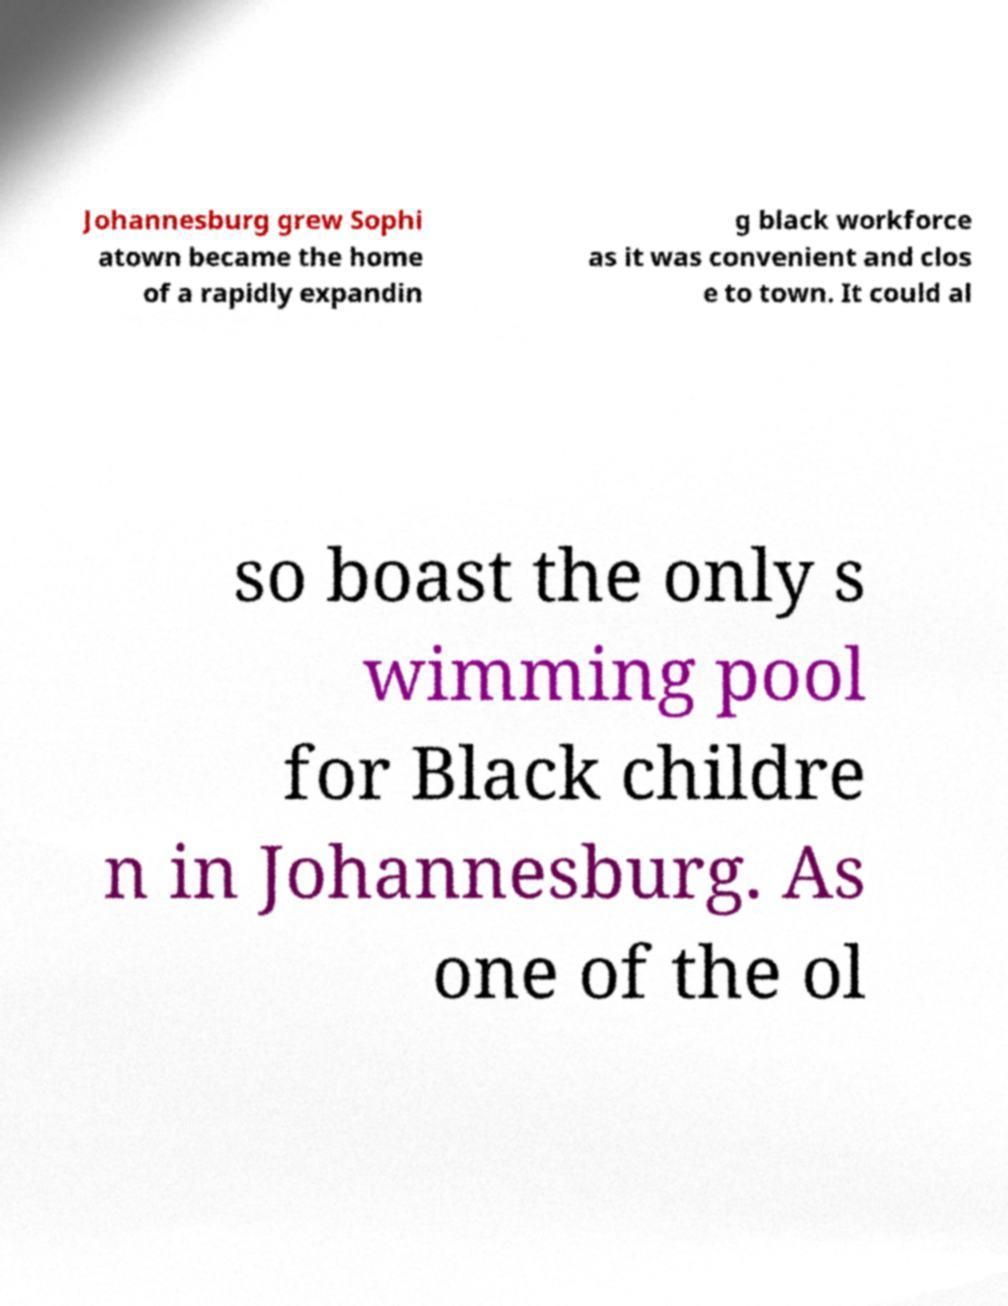What messages or text are displayed in this image? I need them in a readable, typed format. Johannesburg grew Sophi atown became the home of a rapidly expandin g black workforce as it was convenient and clos e to town. It could al so boast the only s wimming pool for Black childre n in Johannesburg. As one of the ol 